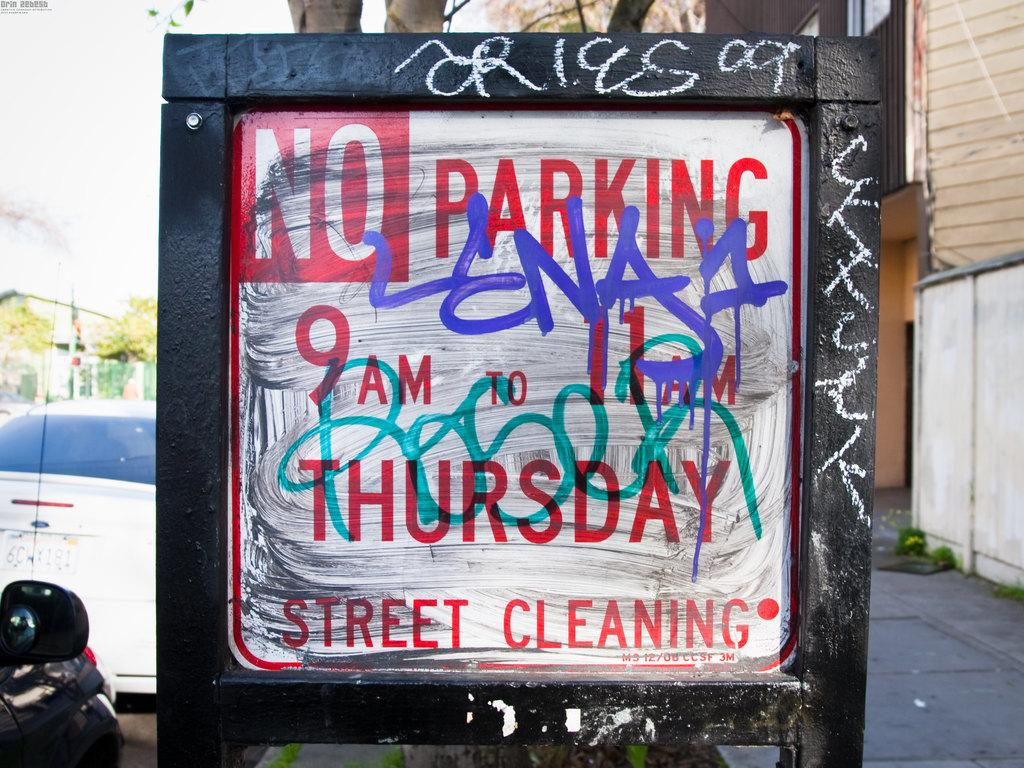What is the main object in the image? There is a board in the image. What is written or displayed on the board? There is text on the board. What can be seen on the left side of the image? There are vehicles on a road on the left side of the image. What is on the right side of the image? There is a footpath on the right side of the image. What type of structures are visible in the image? There are buildings in the image. What type of lamp is hanging from the board in the image? There is no lamp hanging from the board in the image. 